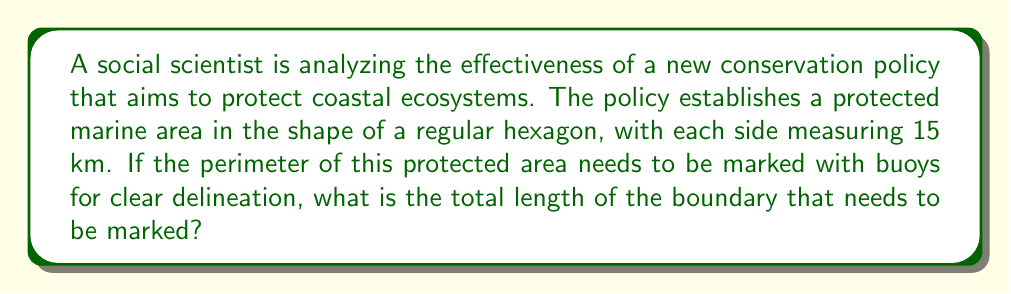Could you help me with this problem? To solve this problem, we need to calculate the perimeter of a regular hexagon. The perimeter of a polygon is the sum of the lengths of all its sides. In a regular hexagon, all sides are equal in length.

Given:
- The protected area is in the shape of a regular hexagon
- Each side of the hexagon measures 15 km

To calculate the perimeter, we use the formula:

$$ P = 6s $$

Where:
$P$ = perimeter of the hexagon
$s$ = length of one side

Substituting the given value:

$$ P = 6 \times 15\text{ km} $$
$$ P = 90\text{ km} $$

This result represents the total length of the boundary that needs to be marked with buoys to delineate the protected marine area.

[asy]
unitsize(1cm);
pair A = (0,0);
pair B = (5,0);
pair C = (7.5,4.33);
pair D = (5,8.66);
pair E = (0,8.66);
pair F = (-2.5,4.33);

draw(A--B--C--D--E--F--cycle);
label("15 km", (A+B)/2, S);
label("15 km", (B+C)/2, SE);
label("15 km", (C+D)/2, NE);
label("15 km", (D+E)/2, N);
label("15 km", (E+F)/2, NW);
label("15 km", (F+A)/2, SW);
[/asy]

This diagram illustrates the hexagonal protected area with each side labeled as 15 km.
Answer: The total length of the boundary that needs to be marked is 90 km. 